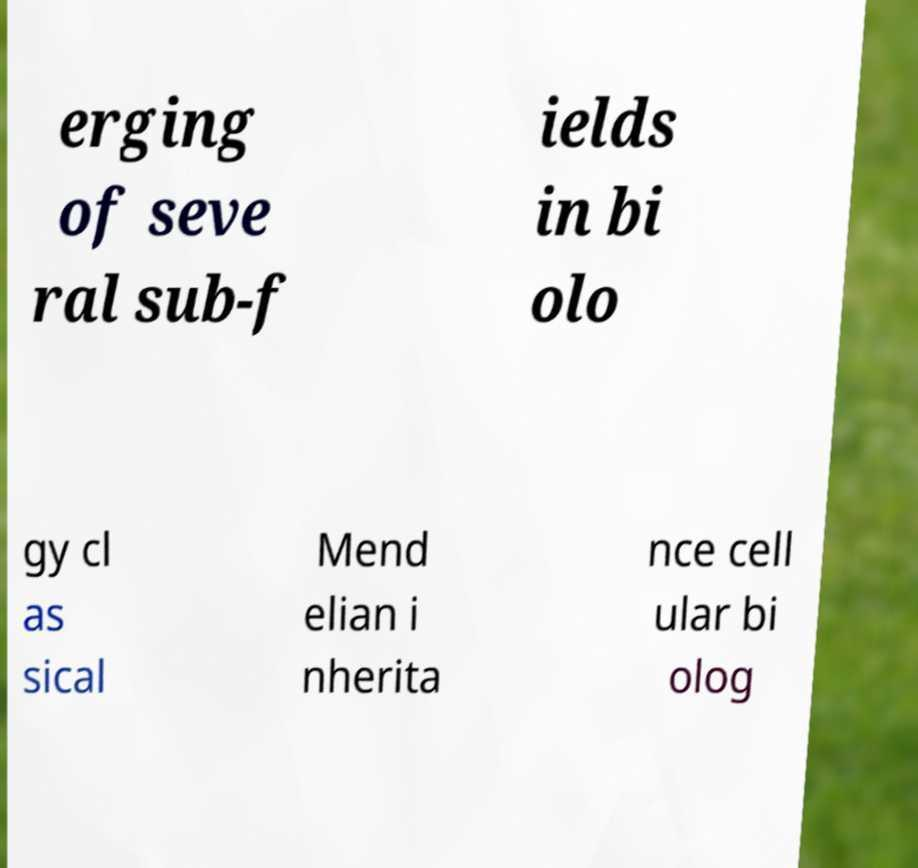I need the written content from this picture converted into text. Can you do that? erging of seve ral sub-f ields in bi olo gy cl as sical Mend elian i nherita nce cell ular bi olog 